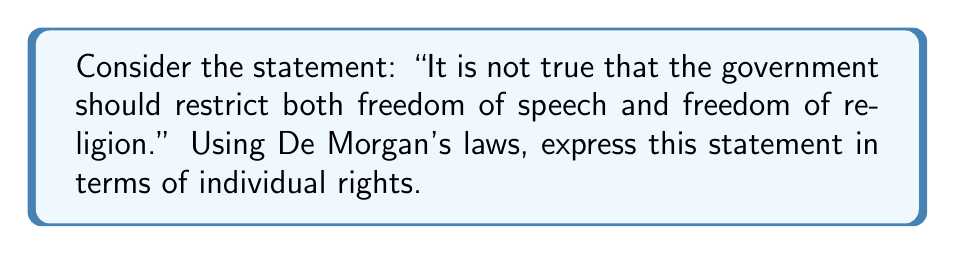Can you solve this math problem? Let's approach this step-by-step:

1) First, let's define our variables:
   $p$: The government should restrict freedom of speech
   $q$: The government should restrict freedom of religion

2) The original statement can be written in Boolean algebra as:
   $$\neg(p \wedge q)$$

3) Applying De Morgan's law, we know that:
   $$\neg(A \wedge B) \equiv \neg A \vee \neg B$$

4) Therefore, our statement becomes:
   $$\neg p \vee \neg q$$

5) In terms of individual rights, this translates to:
   "The government should not restrict freedom of speech OR the government should not restrict freedom of religion"

6) We can further interpret this as:
   "The government should protect freedom of speech OR the government should protect freedom of religion"

This transformation highlights how De Morgan's laws can be used to reframe debates about individual rights, shifting from what the government shouldn't do to what it should do to protect liberties.
Answer: $\neg p \vee \neg q$ 